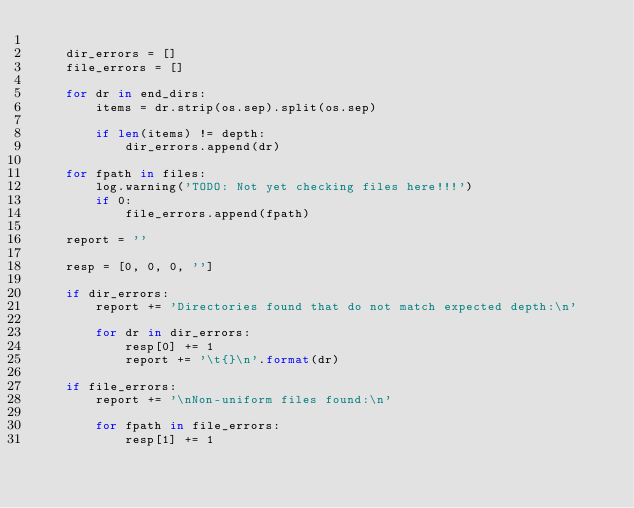Convert code to text. <code><loc_0><loc_0><loc_500><loc_500><_Python_>
    dir_errors = []
    file_errors = []

    for dr in end_dirs:
        items = dr.strip(os.sep).split(os.sep)

        if len(items) != depth:
            dir_errors.append(dr)

    for fpath in files:
        log.warning('TODO: Not yet checking files here!!!')
        if 0:
            file_errors.append(fpath)

    report = ''

    resp = [0, 0, 0, '']

    if dir_errors:
        report += 'Directories found that do not match expected depth:\n'

        for dr in dir_errors:
            resp[0] += 1
            report += '\t{}\n'.format(dr)

    if file_errors:
        report += '\nNon-uniform files found:\n'

        for fpath in file_errors:
            resp[1] += 1</code> 